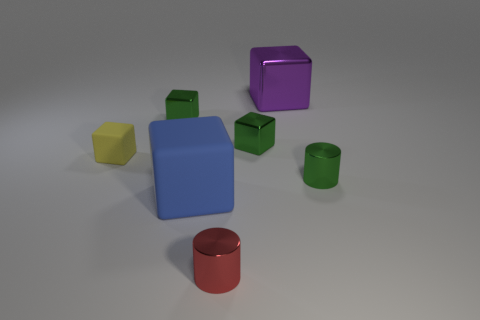Subtract all big purple shiny blocks. How many blocks are left? 4 Subtract all blue cubes. How many cubes are left? 4 Add 3 purple metallic things. How many objects exist? 10 Subtract all gray cubes. Subtract all brown cylinders. How many cubes are left? 5 Add 7 yellow matte cubes. How many yellow matte cubes are left? 8 Add 6 green matte cylinders. How many green matte cylinders exist? 6 Subtract 2 green cubes. How many objects are left? 5 Subtract all cubes. How many objects are left? 2 Subtract all green metallic cylinders. Subtract all green cylinders. How many objects are left? 5 